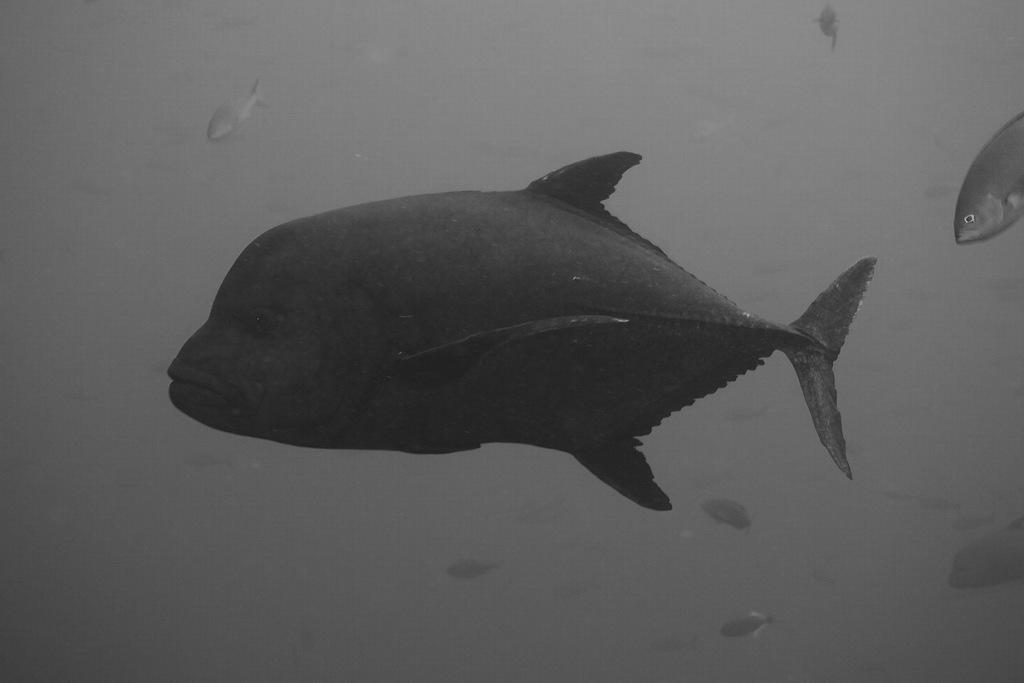What type of artwork is depicted in the image? The image is a painting. What animals are featured in the painting? There are fishes in the painting. Where are the fishes located in the painting? The fishes are in the water. How many books can be seen on the shelf in the painting? There are no bookshelves or books present in the painting; it features fishes in the water. What type of insect is visible in the painting? There are no insects present in the painting; it features fishes in the water. 